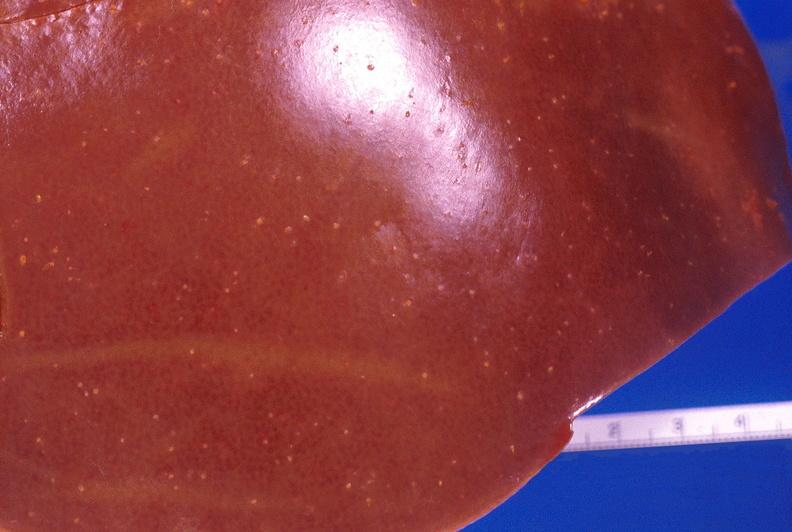s hepatobiliary present?
Answer the question using a single word or phrase. Yes 